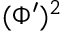Convert formula to latex. <formula><loc_0><loc_0><loc_500><loc_500>( \Phi ^ { \prime } ) ^ { 2 }</formula> 